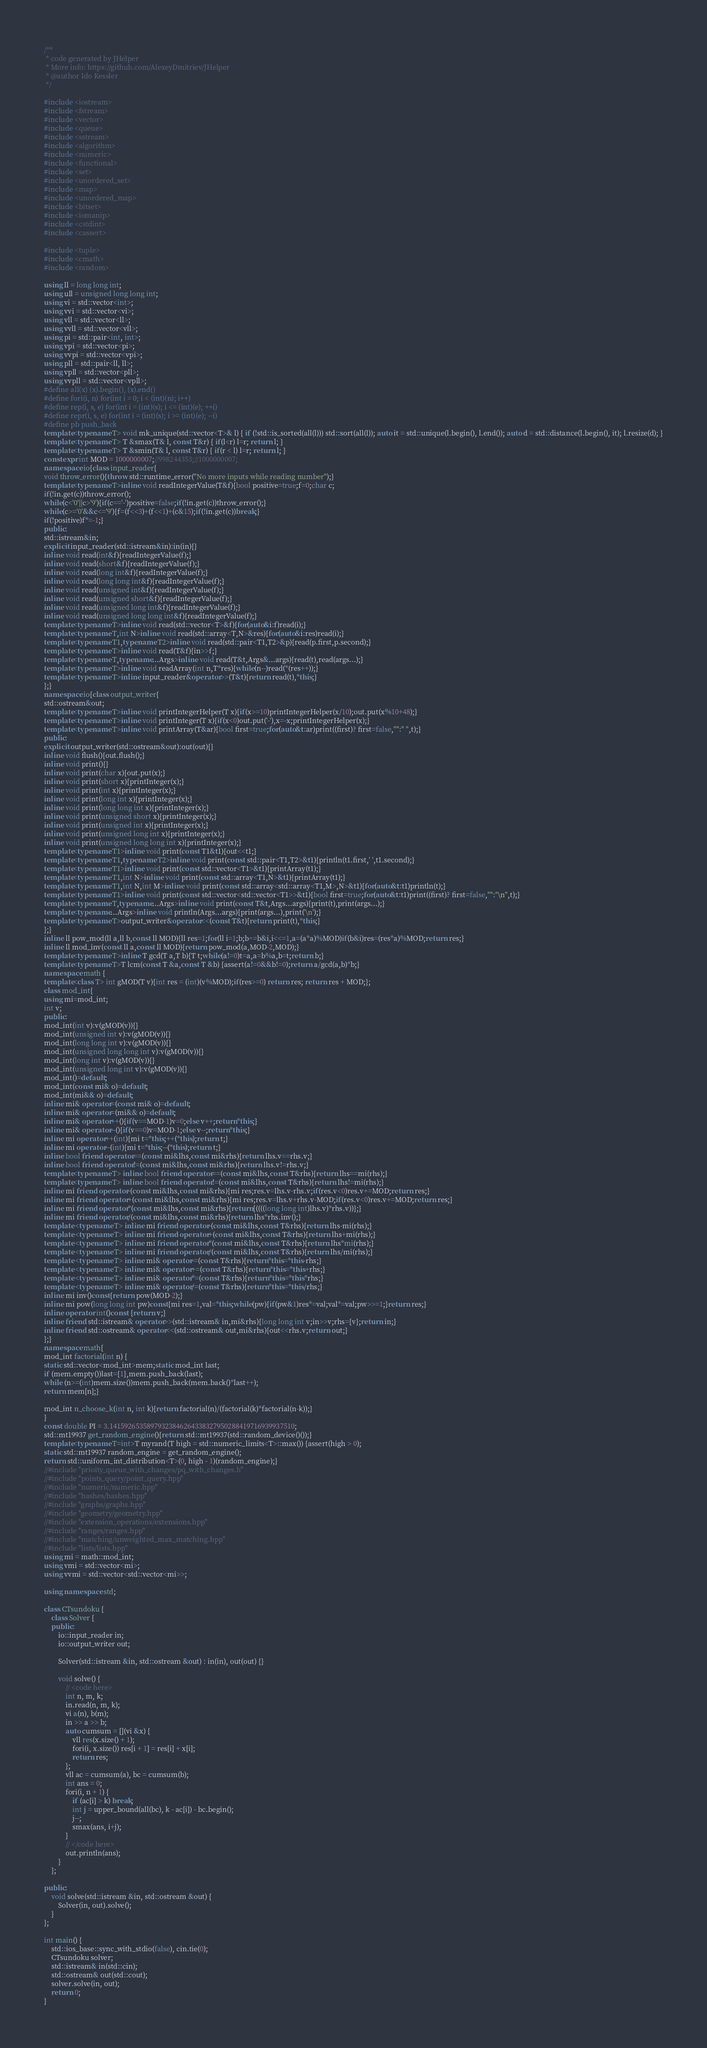<code> <loc_0><loc_0><loc_500><loc_500><_C++_>/**
 * code generated by JHelper
 * More info: https://github.com/AlexeyDmitriev/JHelper
 * @author Ido Kessler
 */

#include <iostream>
#include <fstream>
#include <vector>
#include <queue>
#include <sstream>
#include <algorithm>
#include <numeric>
#include <functional>
#include <set>
#include <unordered_set>
#include <map>
#include <unordered_map>
#include <bitset>
#include <iomanip>
#include <cstdint>
#include <cassert>

#include <tuple>
#include <cmath>
#include <random>

using ll = long long int;
using ull = unsigned long long int;
using vi = std::vector<int>;
using vvi = std::vector<vi>;
using vll = std::vector<ll>;
using vvll = std::vector<vll>;
using pi = std::pair<int, int>;
using vpi = std::vector<pi>;
using vvpi = std::vector<vpi>;
using pll = std::pair<ll, ll>;
using vpll = std::vector<pll>;
using vvpll = std::vector<vpll>;
#define all(x) (x).begin(), (x).end()
#define fori(i, n) for(int i = 0; i < (int)(n); i++)
#define rep(i, s, e) for(int i = (int)(s); i <= (int)(e); ++i)
#define repr(i, s, e) for(int i = (int)(s); i >= (int)(e); --i)
#define pb push_back
template<typename T> void mk_unique(std::vector<T>& l) { if (!std::is_sorted(all(l))) std::sort(all(l)); auto it = std::unique(l.begin(), l.end()); auto d = std::distance(l.begin(), it); l.resize(d); }
template<typename T> T &smax(T& l, const T&r) { if(l<r) l=r; return l; }
template<typename T> T &smin(T& l, const T&r) { if(r < l) l=r; return l; }
constexpr int MOD = 1000000007;//998244353;//1000000007;
namespace io{class input_reader{
void throw_error(){throw std::runtime_error("No more inputs while reading number");}
template<typename T>inline void readIntegerValue(T&f){bool positive=true;f=0;char c;
if(!in.get(c))throw_error();
while(c<'0'||c>'9'){if(c=='-')positive=false;if(!in.get(c))throw_error();}
while(c>='0'&&c<='9'){f=(f<<3)+(f<<1)+(c&15);if(!in.get(c))break;}
if(!positive)f*=-1;}
public:
std::istream&in;
explicit input_reader(std::istream&in):in(in){}
inline void read(int&f){readIntegerValue(f);}
inline void read(short&f){readIntegerValue(f);}
inline void read(long int&f){readIntegerValue(f);}
inline void read(long long int&f){readIntegerValue(f);}
inline void read(unsigned int&f){readIntegerValue(f);}
inline void read(unsigned short&f){readIntegerValue(f);}
inline void read(unsigned long int&f){readIntegerValue(f);}
inline void read(unsigned long long int&f){readIntegerValue(f);}
template<typename T>inline void read(std::vector<T>&f){for(auto&i:f)read(i);}
template<typename T,int N>inline void read(std::array<T,N>&res){for(auto&i:res)read(i);}
template<typename T1,typename T2>inline void read(std::pair<T1,T2>&p){read(p.first,p.second);}
template<typename T>inline void read(T&f){in>>f;}
template<typename T,typename...Args>inline void read(T&t,Args&...args){read(t),read(args...);}
template<typename T>inline void readArray(int n,T*res){while(n--)read(*(res++));}
template<typename T>inline input_reader&operator>>(T&t){return read(t),*this;}
};}
namespace io{class output_writer{
std::ostream&out;
template<typename T>inline void printIntegerHelper(T x){if(x>=10)printIntegerHelper(x/10);out.put(x%10+48);}
template<typename T>inline void printInteger(T x){if(x<0)out.put('-'),x=-x;printIntegerHelper(x);}
template<typename T>inline void printArray(T&ar){bool first=true;for(auto&t:ar)print((first)? first=false,"":" ",t);}
public:
explicit output_writer(std::ostream&out):out(out){}
inline void flush(){out.flush();}
inline void print(){}
inline void print(char x){out.put(x);}
inline void print(short x){printInteger(x);}
inline void print(int x){printInteger(x);}
inline void print(long int x){printInteger(x);}
inline void print(long long int x){printInteger(x);}
inline void print(unsigned short x){printInteger(x);}
inline void print(unsigned int x){printInteger(x);}
inline void print(unsigned long int x){printInteger(x);}
inline void print(unsigned long long int x){printInteger(x);}
template<typename T1>inline void print(const T1&t1){out<<t1;}
template<typename T1,typename T2>inline void print(const std::pair<T1,T2>&t1){println(t1.first,' ',t1.second);}
template<typename T1>inline void print(const std::vector<T1>&t1){printArray(t1);}
template<typename T1,int N>inline void print(const std::array<T1,N>&t1){printArray(t1);}
template<typename T1,int N,int M>inline void print(const std::array<std::array<T1,M>,N>&t1){for(auto&t:t1)println(t);}
template<typename T1>inline void print(const std::vector<std::vector<T1>>&t1){bool first=true;for(auto&t:t1)print((first)? first=false,"":"\n",t);}
template<typename T,typename...Args>inline void print(const T&t,Args...args){print(t),print(args...);}
template<typename...Args>inline void println(Args...args){print(args...),print('\n');}
template<typename T>output_writer&operator<<(const T&t){return print(t),*this;}
};}
inline ll pow_mod(ll a,ll b,const ll MOD){ll res=1;for(ll i=1;b;b^=b&i,i<<=1,a=(a*a)%MOD)if(b&i)res=(res*a)%MOD;return res;}
inline ll mod_inv(const ll a,const ll MOD){return pow_mod(a,MOD-2,MOD);}
template<typename T>inline T gcd(T a,T b){T t;while(a!=0)t=a,a=b%a,b=t;return b;}
template<typename T>T lcm(const T &a,const T &b) {assert(a!=0&&b!=0);return a/gcd(a,b)*b;}
namespace math {
template<class T> int gMOD(T v){int res = (int)(v%MOD);if(res>=0) return res; return res + MOD;};
class mod_int{
using mi=mod_int;
int v;
public:
mod_int(int v):v(gMOD(v)){}
mod_int(unsigned int v):v(gMOD(v)){}
mod_int(long long int v):v(gMOD(v)){}
mod_int(unsigned long long int v):v(gMOD(v)){}
mod_int(long int v):v(gMOD(v)){}
mod_int(unsigned long int v):v(gMOD(v)){}
mod_int()=default;
mod_int(const mi& o)=default;
mod_int(mi&& o)=default;
inline mi& operator=(const mi& o)=default;
inline mi& operator=(mi&& o)=default;
inline mi& operator++(){if(v==MOD-1)v=0;else v++;return*this;}
inline mi& operator--(){if(v==0)v=MOD-1;else v--;return*this;}
inline mi operator++(int){mi t=*this;++(*this);return t;}
inline mi operator--(int){mi t=*this;--(*this);return t;}
inline bool friend operator==(const mi&lhs,const mi&rhs){return lhs.v==rhs.v;}
inline bool friend operator!=(const mi&lhs,const mi&rhs){return lhs.v!=rhs.v;}
template<typename T> inline bool friend operator==(const mi&lhs,const T&rhs){return lhs==mi(rhs);}
template<typename T> inline bool friend operator!=(const mi&lhs,const T&rhs){return lhs!=mi(rhs);}
inline mi friend operator-(const mi&lhs,const mi&rhs){mi res;res.v=lhs.v-rhs.v;if(res.v<0)res.v+=MOD;return res;}
inline mi friend operator+(const mi&lhs,const mi&rhs){mi res;res.v=lhs.v+rhs.v-MOD;if(res.v<0)res.v+=MOD;return res;}
inline mi friend operator*(const mi&lhs,const mi&rhs){return{((((long long int)lhs.v)*rhs.v))};}
inline mi friend operator/(const mi&lhs,const mi&rhs){return lhs*rhs.inv();}
template <typename T> inline mi friend operator-(const mi&lhs,const T&rhs){return lhs-mi(rhs);}
template <typename T> inline mi friend operator+(const mi&lhs,const T&rhs){return lhs+mi(rhs);}
template <typename T> inline mi friend operator*(const mi&lhs,const T&rhs){return lhs*mi(rhs);}
template <typename T> inline mi friend operator/(const mi&lhs,const T&rhs){return lhs/mi(rhs);}
template <typename T> inline mi& operator-=(const T&rhs){return*this=*this-rhs;}
template <typename T> inline mi& operator+=(const T&rhs){return*this=*this+rhs;}
template <typename T> inline mi& operator*=(const T&rhs){return*this=*this*rhs;}
template <typename T> inline mi& operator/=(const T&rhs){return*this=*this/rhs;}
inline mi inv()const{return pow(MOD-2);}
inline mi pow(long long int pw)const{mi res=1,val=*this;while(pw){if(pw&1)res*=val;val*=val;pw>>=1;}return res;}
inline operator int()const {return v;}
inline friend std::istream& operator>>(std::istream& in,mi&rhs){long long int v;in>>v;rhs={v};return in;}
inline friend std::ostream& operator<<(std::ostream& out,mi&rhs){out<<rhs.v;return out;}
};}
namespace math{
mod_int factorial(int n) {
static std::vector<mod_int>mem;static mod_int last;
if (mem.empty())last={1},mem.push_back(last);
while (n>=(int)mem.size())mem.push_back(mem.back()*last++);
return mem[n];}

mod_int n_choose_k(int n, int k){return factorial(n)/(factorial(k)*factorial(n-k));}
}
const double PI = 3.14159265358979323846264338327950288419716939937510;
std::mt19937 get_random_engine(){return std::mt19937(std::random_device()());}
template<typename T=int>T myrand(T high = std::numeric_limits<T>::max()) {assert(high > 0);
static std::mt19937 random_engine = get_random_engine();
return std::uniform_int_distribution<T>(0, high - 1)(random_engine);}
//#include "prioity_queue_with_changes/pq_with_changes.h"
//#include "points_query/point_query.hpp"
//#include "numeric/numeric.hpp"
//#include "hashes/hashes.hpp"
//#include "graphs/graphs.hpp"
//#include "geometry/geometry.hpp"
//#include "extension_operations/extensions.hpp"
//#include "ranges/ranges.hpp"
//#include "matching/unweighted_max_matching.hpp"
//#include "lists/lists.hpp"
using mi = math::mod_int;
using vmi = std::vector<mi>;
using vvmi = std::vector<std::vector<mi>>;

using namespace std;

class CTsundoku {
    class Solver {
    public:
        io::input_reader in;
        io::output_writer out;

        Solver(std::istream &in, std::ostream &out) : in(in), out(out) {}

        void solve() {
            // <code here>
            int n, m, k;
            in.read(n, m, k);
            vi a(n), b(m);
            in >> a >> b;
            auto cumsum = [](vi &x) {
                vll res(x.size() + 1);
                fori(i, x.size()) res[i + 1] = res[i] + x[i];
                return res;
            };
            vll ac = cumsum(a), bc = cumsum(b);
            int ans = 0;
            fori(i, n + 1) {
                if (ac[i] > k) break;
                int j = upper_bound(all(bc), k - ac[i]) - bc.begin();
                j--;
                smax(ans, i+j);
            }
            // </code here>
            out.println(ans);
        }
    };

public:
    void solve(std::istream &in, std::ostream &out) {
        Solver(in, out).solve();
    }
};

int main() {
	std::ios_base::sync_with_stdio(false), cin.tie(0);
	CTsundoku solver;
	std::istream& in(std::cin);
	std::ostream& out(std::cout);
	solver.solve(in, out);
	return 0;
}
</code> 